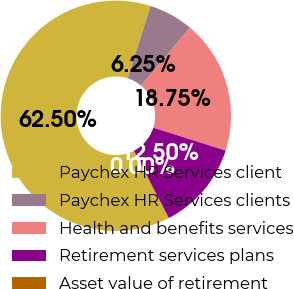<chart> <loc_0><loc_0><loc_500><loc_500><pie_chart><fcel>Paychex HR Services client<fcel>Paychex HR Services clients<fcel>Health and benefits services<fcel>Retirement services plans<fcel>Asset value of retirement<nl><fcel>62.5%<fcel>6.25%<fcel>18.75%<fcel>12.5%<fcel>0.0%<nl></chart> 